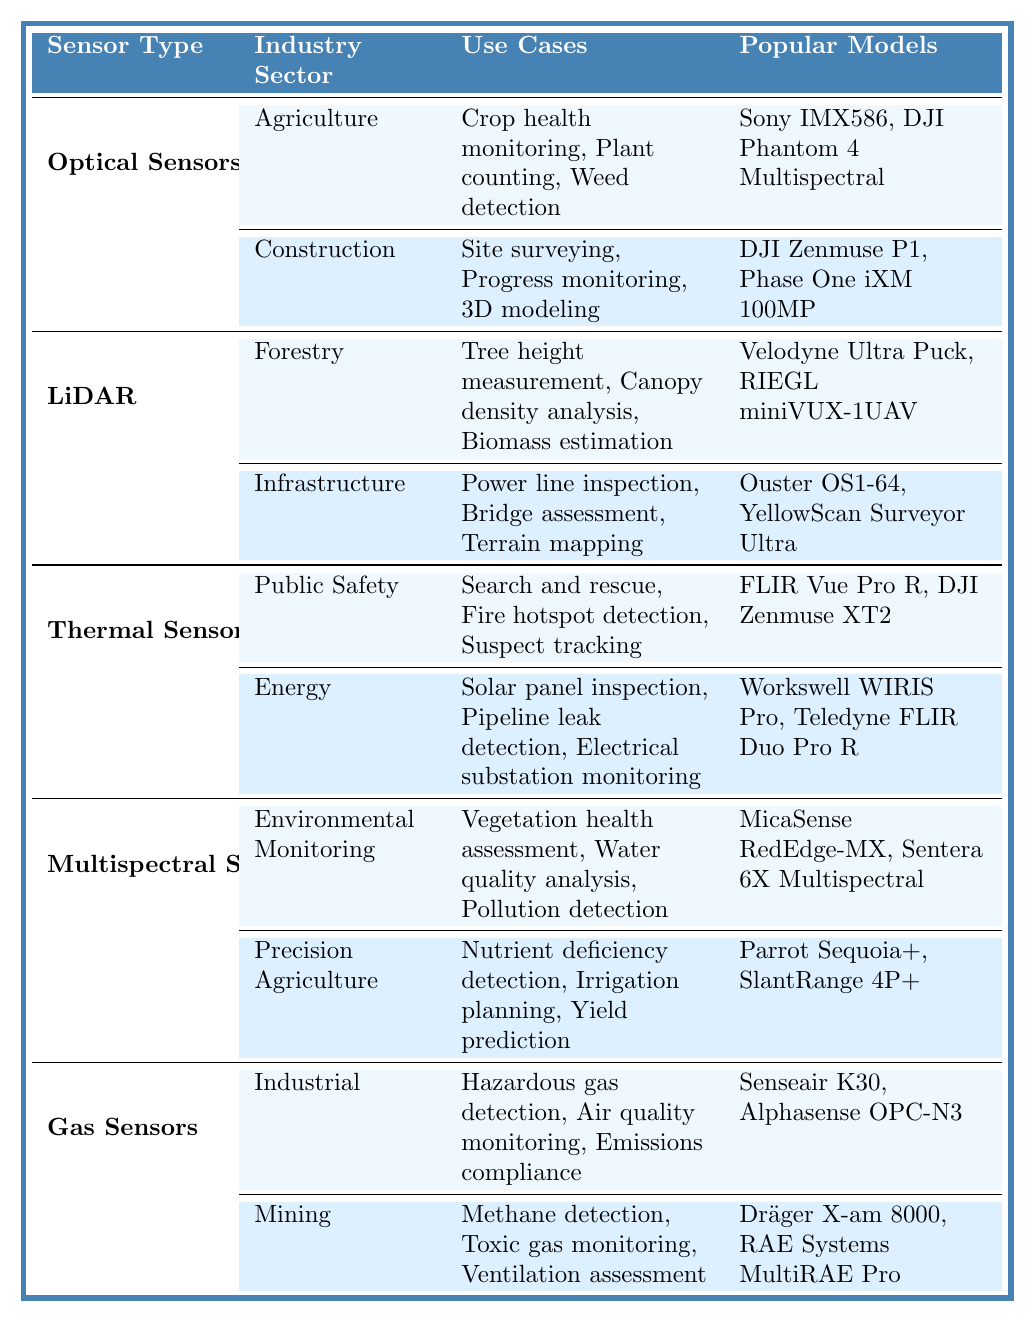What are the popular models for Optical Sensors in Agriculture? The table lists the popular models under the Optical Sensors category for Agriculture, which include Sony IMX586 and DJI Phantom 4 Multispectral.
Answer: Sony IMX586, DJI Phantom 4 Multispectral Which industry sector uses LiDAR for bridge assessment? The table shows that the Infrastructure industry sector uses LiDAR for bridge assessment.
Answer: Infrastructure How many use cases are listed for Thermal Sensors in Public Safety? For Thermal Sensors in Public Safety, the table lists three use cases: Search and rescue, Fire hotspot detection, and Suspect tracking. Thus, there are 3 use cases in total.
Answer: 3 Is the FLIR Vue Pro R used in Energy applications? The table indicates that the FLIR Vue Pro R is listed under the popular models for Thermal Sensors, specifically in the Public Safety applications, not Energy applications.
Answer: No Which sensor type has applications in both Agriculture and Construction? The Optical Sensors sensor type has applications in both Agriculture (crop health monitoring, etc.) and Construction (site surveying, etc.) as stated in the table.
Answer: Optical Sensors What is the sum of the number of use cases for Gas Sensors in Industrial and Mining sectors? There are three use cases for Gas Sensors in Industrial (Hazardous gas detection, Air quality monitoring, Emissions compliance) and three in Mining (Methane detection, Toxic gas monitoring, Ventilation assessment). Adding both gives 3 + 3 = 6 use cases in total.
Answer: 6 List all the use cases related to Multispectral Sensors. The table details the use cases for Multispectral Sensors across two industry sectors: Environmental Monitoring (Vegetation health assessment, Water quality analysis, Pollution detection) and Precision Agriculture (Nutrient deficiency detection, Irrigation planning, Yield prediction), totaling five unique use cases.
Answer: 5 Are the popular models for LiDAR in Forestry the same as those in Infrastructure? The table specifies that the popular models for LiDAR in Forestry are Velodyne Ultra Puck and RIEGL miniVUX-1UAV, while for Infrastructure, they are Ouster OS1-64 and YellowScan Surveyor Ultra, indicating they are not the same.
Answer: No Which sensor type has the maximum number of industry sectors listed? The table features Optical Sensors in two sectors, LiDAR in two sectors, Thermal Sensors in two sectors, Multispectral Sensors in two sectors, and Gas Sensors in two sectors. Therefore, all sensor types listed have the same number of industry sectors.
Answer: None, all have 2 sectors In how many industry sectors are Gas Sensors used? The table shows that Gas Sensors have applications in two industry sectors: Industrial and Mining, resulting in a total of 2 sectors.
Answer: 2 